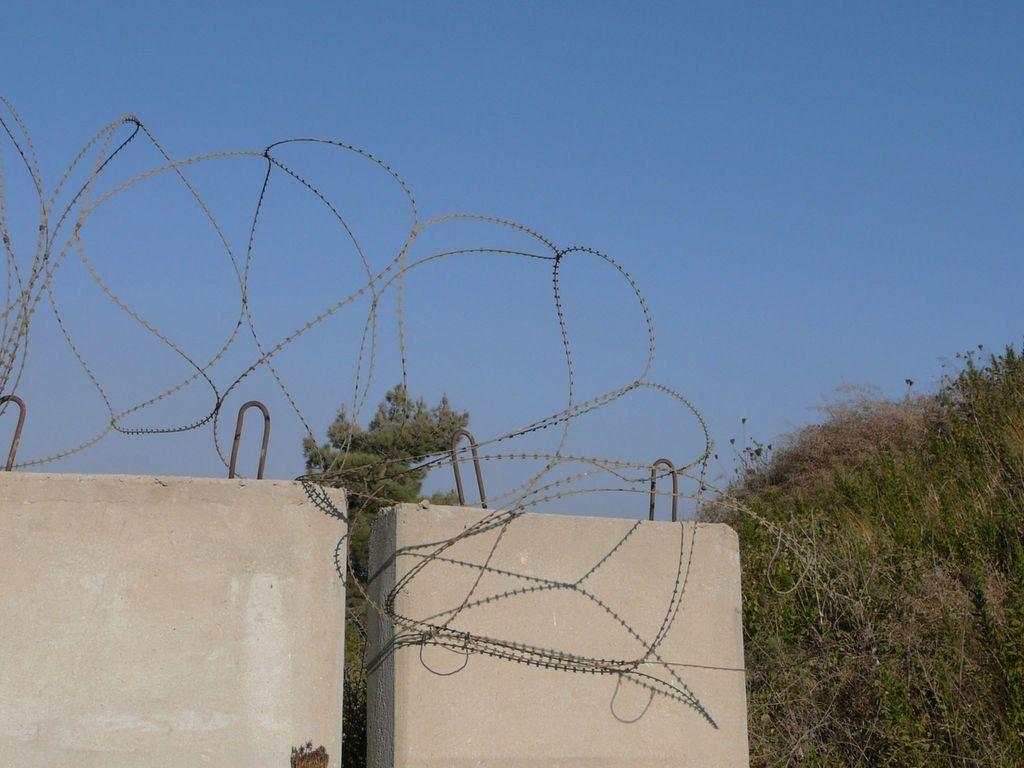What type of structures can be seen in the image? There are walls in the image. What type of vegetation is present in the image? There are plants in the image. What material is the iron wire made of? The iron wire in the image is made of iron. What is visible in the background of the image? The sky is visible in the background of the image. How many horses are running through the stream in the image? There is no stream or horses present in the image. What type of death is depicted in the image? There is no depiction of death in the image; it features walls, plants, and an iron wire. 